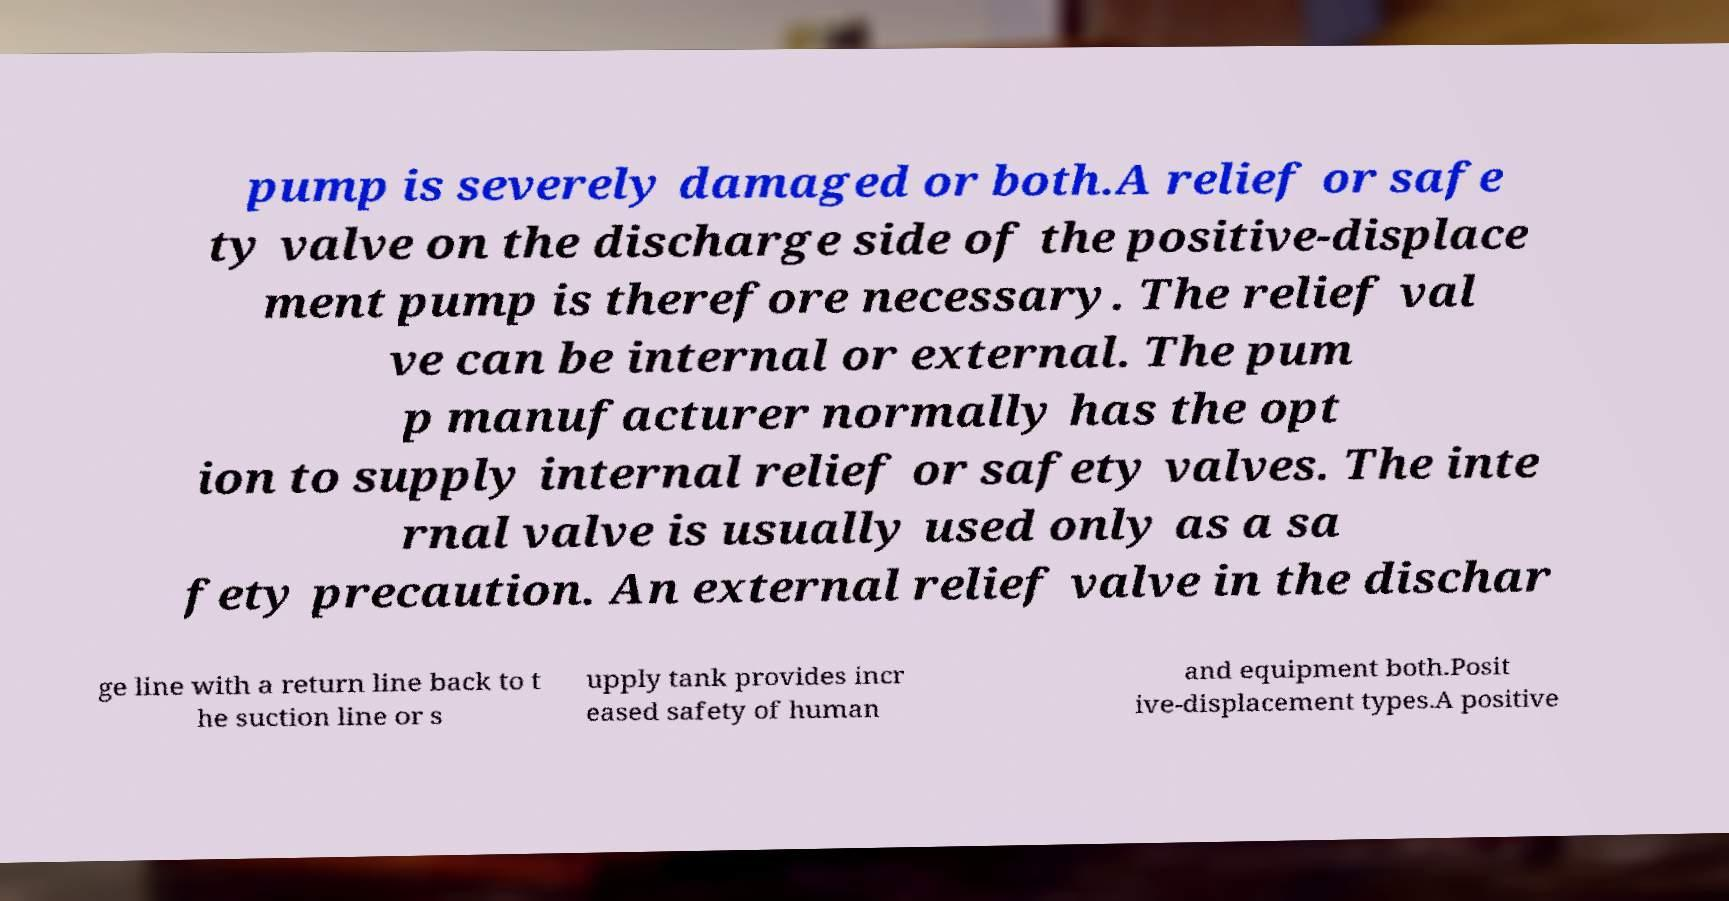Could you extract and type out the text from this image? pump is severely damaged or both.A relief or safe ty valve on the discharge side of the positive-displace ment pump is therefore necessary. The relief val ve can be internal or external. The pum p manufacturer normally has the opt ion to supply internal relief or safety valves. The inte rnal valve is usually used only as a sa fety precaution. An external relief valve in the dischar ge line with a return line back to t he suction line or s upply tank provides incr eased safety of human and equipment both.Posit ive-displacement types.A positive 